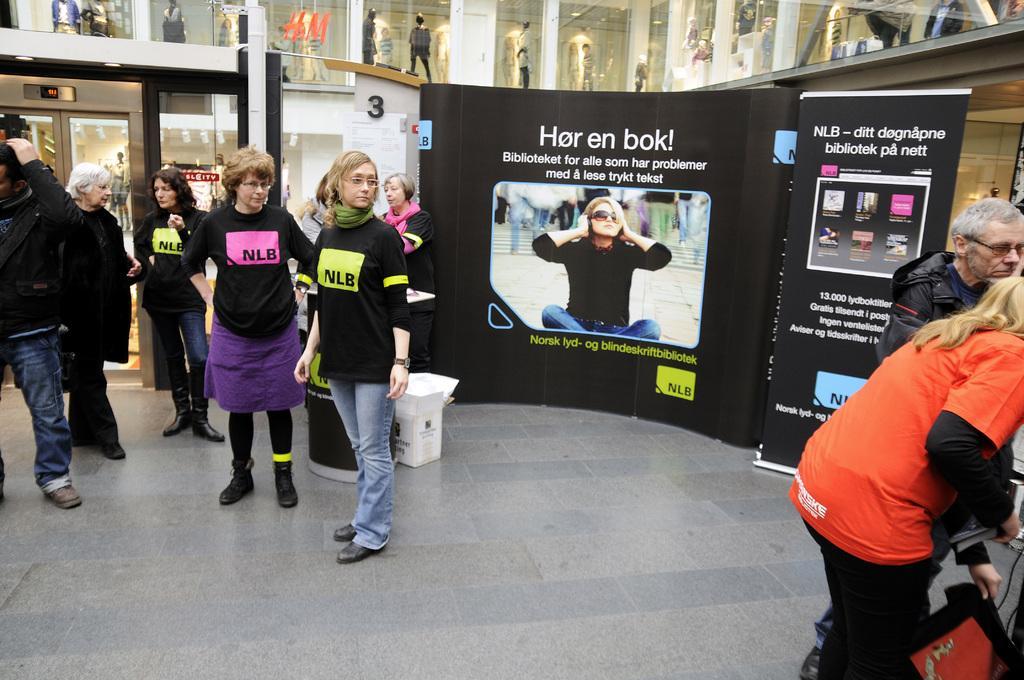Could you give a brief overview of what you see in this image? In this image, we can see some persons standing and wearing clothes. There is a banner in the middle of the image. There are some display models at the top of the image. 